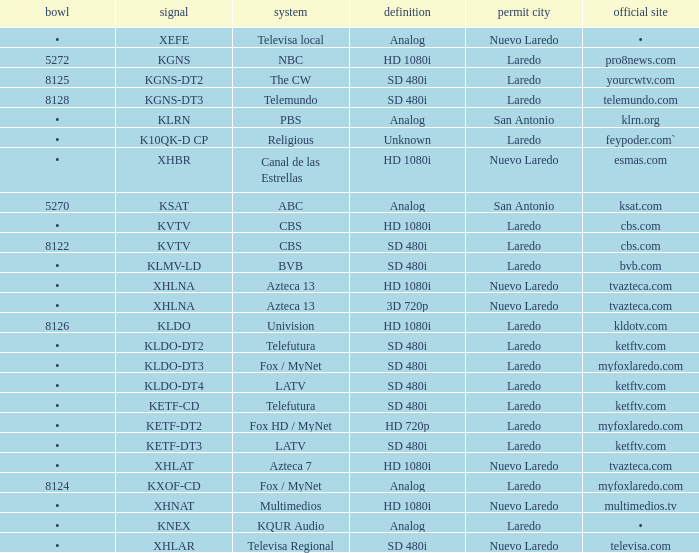Name the official website which has dish of • and callsign of kvtv Cbs.com. 